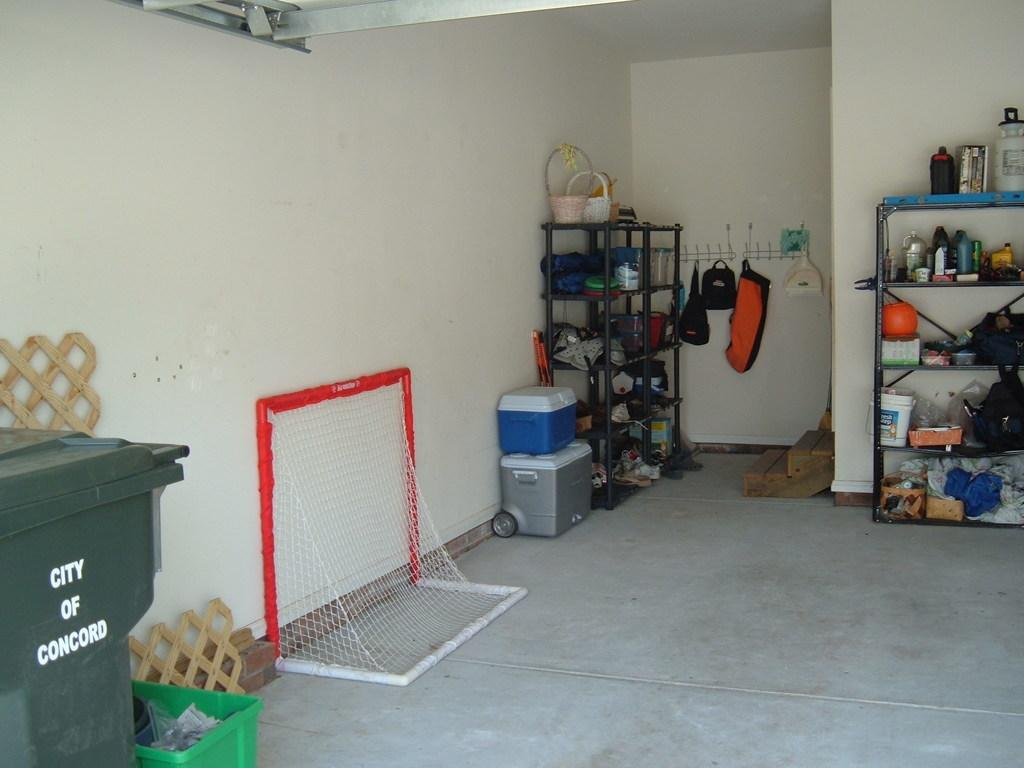Provide a one-sentence caption for the provided image. A garbage can from Concord is sitting in the edge of a garage. 